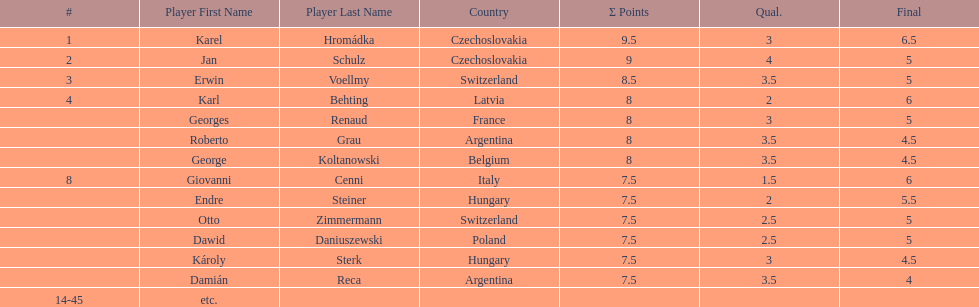How many players had final scores higher than 5? 4. 